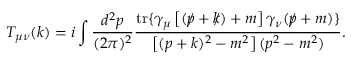<formula> <loc_0><loc_0><loc_500><loc_500>T _ { \mu \nu } ( k ) = i \int \frac { d ^ { 2 } p } { ( 2 \pi ) ^ { 2 } } \frac { t r \{ \gamma _ { \mu } \left [ ( p \, \slash + k \, \slash ) + m \right ] \gamma _ { \nu } ( p \, \slash + m ) \} } { \left [ ( p + k ) ^ { 2 } - m ^ { 2 } \right ] ( p ^ { 2 } - m ^ { 2 } ) } .</formula> 